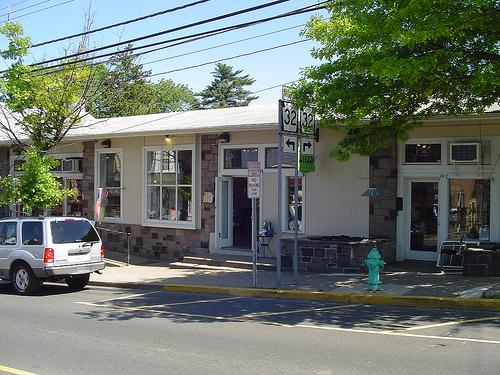Question: where was the picture taken?
Choices:
A. In street.
B. At the store.
C. At the mall.
D. In theater.
Answer with the letter. Answer: A Question: what number is on the road sign?
Choices:
A. 34.
B. 23.
C. 32.
D. 28.
Answer with the letter. Answer: C Question: where is the fire hydrant?
Choices:
A. Near the parking meter.
B. On sidewalk.
C. On the cul-de-sac.
D. Near light pole.
Answer with the letter. Answer: B Question: what kind of vehicle is in the picture?
Choices:
A. Sedan.
B. Jeep.
C. Convertible car.
D. Suv.
Answer with the letter. Answer: D Question: what color is the sky?
Choices:
A. Grey.
B. Blue.
C. Purple.
D. Orange.
Answer with the letter. Answer: B Question: what kind of building are in the picture?
Choices:
A. Offices.
B. Schools.
C. Stores.
D. Factory.
Answer with the letter. Answer: C 